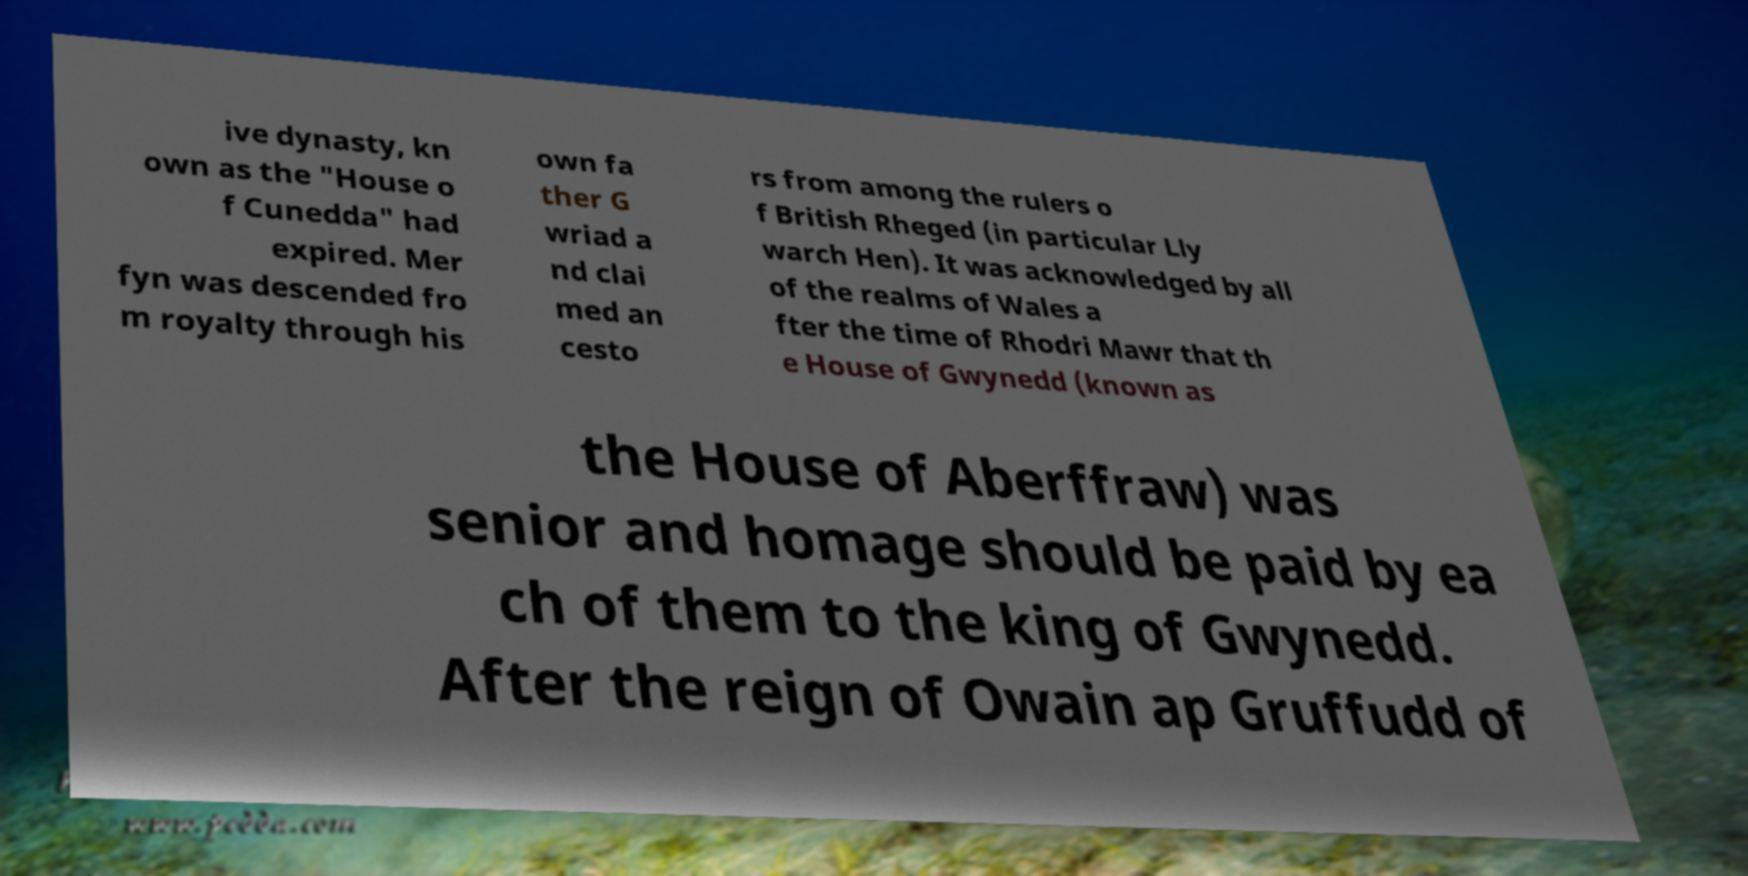There's text embedded in this image that I need extracted. Can you transcribe it verbatim? ive dynasty, kn own as the "House o f Cunedda" had expired. Mer fyn was descended fro m royalty through his own fa ther G wriad a nd clai med an cesto rs from among the rulers o f British Rheged (in particular Lly warch Hen). It was acknowledged by all of the realms of Wales a fter the time of Rhodri Mawr that th e House of Gwynedd (known as the House of Aberffraw) was senior and homage should be paid by ea ch of them to the king of Gwynedd. After the reign of Owain ap Gruffudd of 